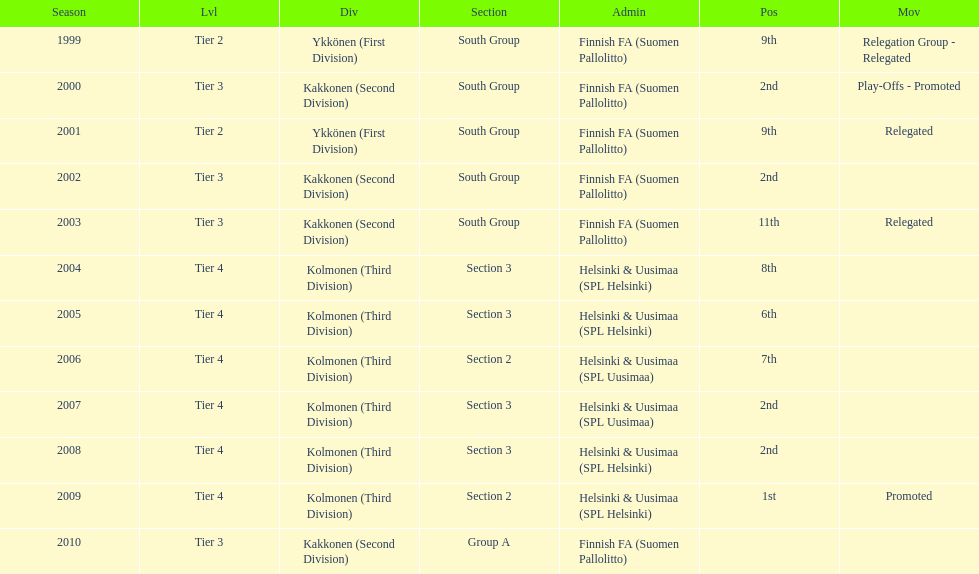When was the last year they placed 2nd? 2008. 